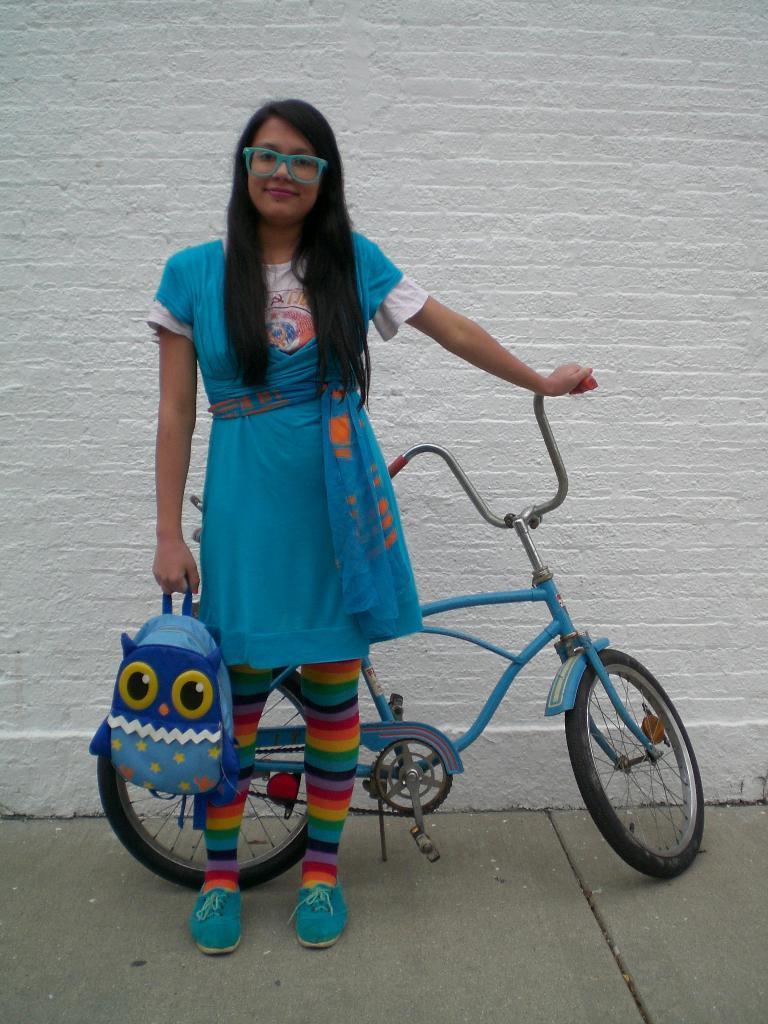How would you summarize this image in a sentence or two? In this picture I can see there is a woman standing here and she is wearing a blue dress, blue shoes and she is holding a blue bag and there is a blue bicycle and there is a white wall in the backdrop. 